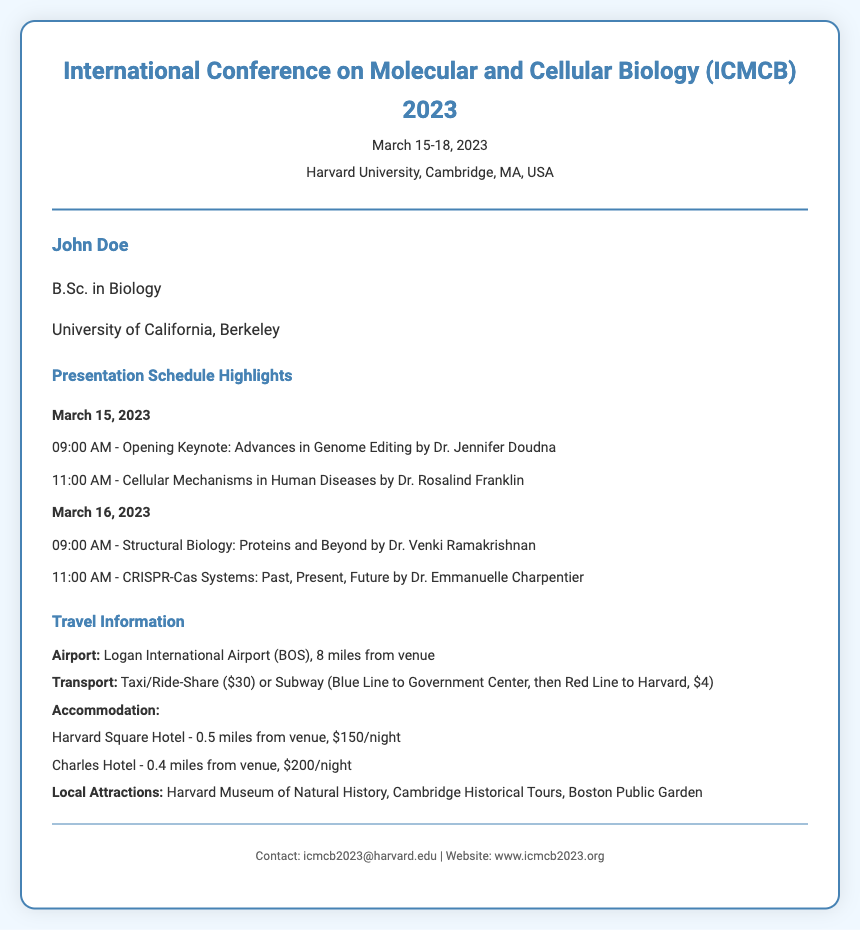What is the name of the conference? The title of the conference is mentioned prominently at the top of the document as 'International Conference on Molecular and Cellular Biology (ICMCB) 2023'.
Answer: International Conference on Molecular and Cellular Biology (ICMCB) 2023 What are the dates of the conference? The document provides specific dates for the conference, listed as 'March 15-18, 2023'.
Answer: March 15-18, 2023 Who is the keynote speaker on March 15, 2023? The document lists Dr. Jennifer Doudna as the opening keynote speaker for the specified date.
Answer: Dr. Jennifer Doudna What is the location of the conference? The conference takes place at 'Harvard University, Cambridge, MA, USA', as stated in the document.
Answer: Harvard University, Cambridge, MA, USA What is the distance from Logan International Airport to the venue? The travel information specifies that the airport is '8 miles' from the venue.
Answer: 8 miles What is the cost of a taxi ride from the airport? The document indicates that a taxi or ride-share from the airport costs '$30'.
Answer: $30 Which hotel is closest to the venue? The 'Charles Hotel' is mentioned as being '0.4 miles from venue', making it the closest accommodation option.
Answer: Charles Hotel What is the total number of presentation events listed in the schedule? The schedule outlines a total of five presentation events across two days.
Answer: 5 What are two local attractions mentioned in the travel section? The document lists 'Harvard Museum of Natural History' and 'Cambridge Historical Tours' as local attractions.
Answer: Harvard Museum of Natural History, Cambridge Historical Tours 